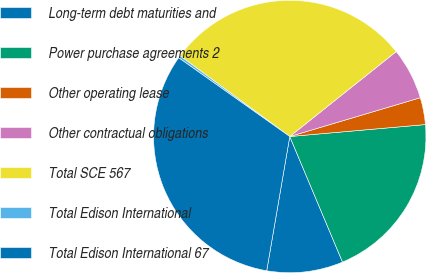Convert chart to OTSL. <chart><loc_0><loc_0><loc_500><loc_500><pie_chart><fcel>Long-term debt maturities and<fcel>Power purchase agreements 2<fcel>Other operating lease<fcel>Other contractual obligations<fcel>Total SCE 567<fcel>Total Edison International<fcel>Total Edison International 67<nl><fcel>9.04%<fcel>20.07%<fcel>3.2%<fcel>6.12%<fcel>29.19%<fcel>0.28%<fcel>32.11%<nl></chart> 